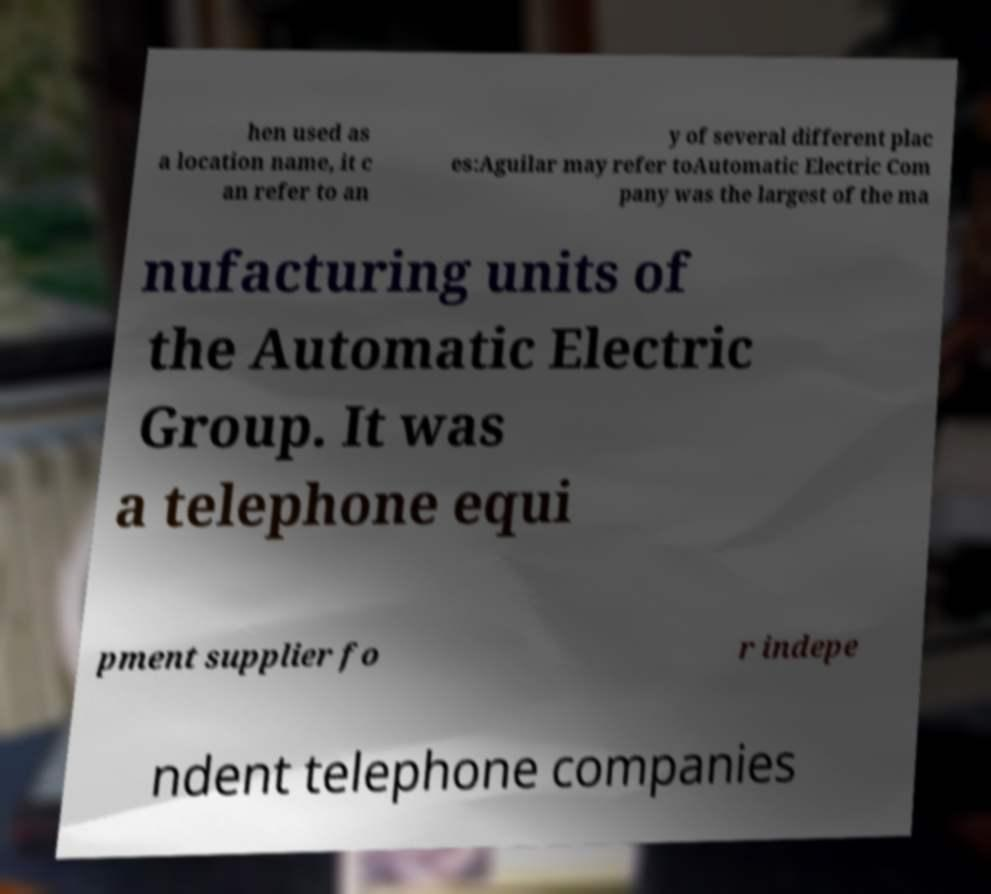There's text embedded in this image that I need extracted. Can you transcribe it verbatim? hen used as a location name, it c an refer to an y of several different plac es:Aguilar may refer toAutomatic Electric Com pany was the largest of the ma nufacturing units of the Automatic Electric Group. It was a telephone equi pment supplier fo r indepe ndent telephone companies 